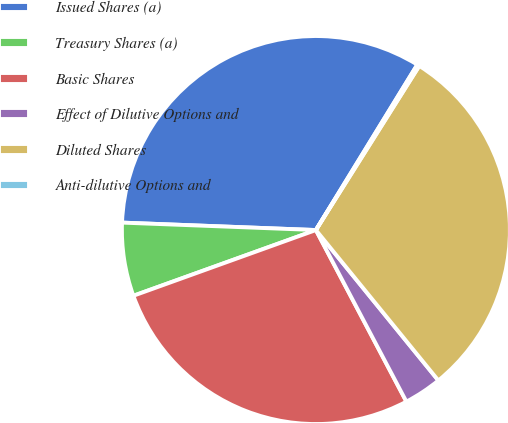<chart> <loc_0><loc_0><loc_500><loc_500><pie_chart><fcel>Issued Shares (a)<fcel>Treasury Shares (a)<fcel>Basic Shares<fcel>Effect of Dilutive Options and<fcel>Diluted Shares<fcel>Anti-dilutive Options and<nl><fcel>33.14%<fcel>6.11%<fcel>27.22%<fcel>3.15%<fcel>30.18%<fcel>0.19%<nl></chart> 